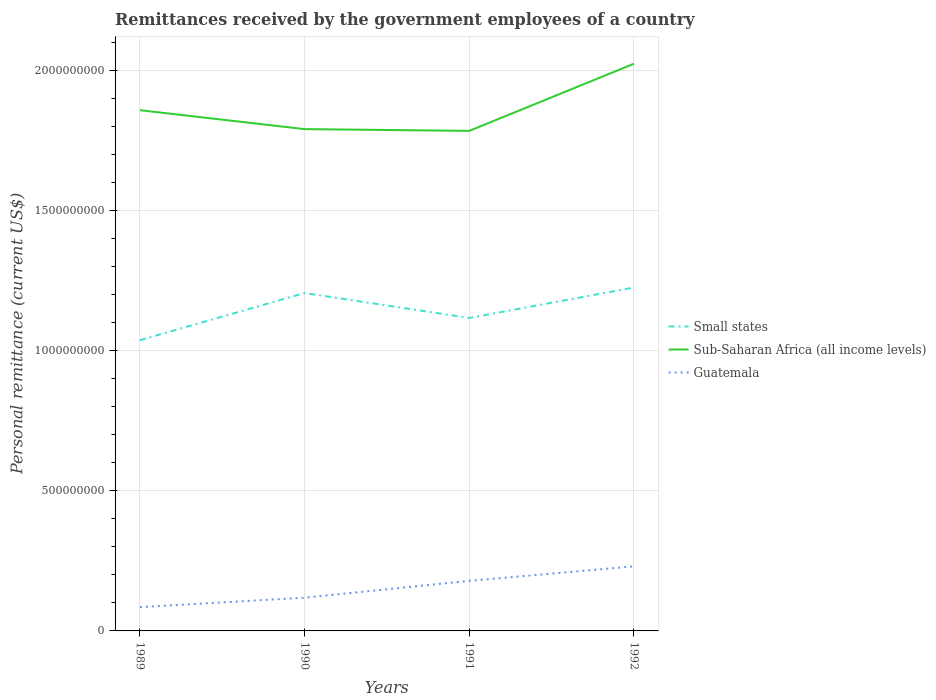How many different coloured lines are there?
Provide a succinct answer. 3. Is the number of lines equal to the number of legend labels?
Your answer should be compact. Yes. Across all years, what is the maximum remittances received by the government employees in Small states?
Your response must be concise. 1.04e+09. In which year was the remittances received by the government employees in Small states maximum?
Your answer should be very brief. 1989. What is the total remittances received by the government employees in Sub-Saharan Africa (all income levels) in the graph?
Provide a short and direct response. -2.40e+08. What is the difference between the highest and the second highest remittances received by the government employees in Small states?
Give a very brief answer. 1.88e+08. What is the difference between the highest and the lowest remittances received by the government employees in Sub-Saharan Africa (all income levels)?
Give a very brief answer. 1. How many years are there in the graph?
Your answer should be compact. 4. Are the values on the major ticks of Y-axis written in scientific E-notation?
Make the answer very short. No. How are the legend labels stacked?
Provide a short and direct response. Vertical. What is the title of the graph?
Your answer should be compact. Remittances received by the government employees of a country. Does "Low & middle income" appear as one of the legend labels in the graph?
Provide a short and direct response. No. What is the label or title of the Y-axis?
Provide a short and direct response. Personal remittance (current US$). What is the Personal remittance (current US$) of Small states in 1989?
Ensure brevity in your answer.  1.04e+09. What is the Personal remittance (current US$) of Sub-Saharan Africa (all income levels) in 1989?
Ensure brevity in your answer.  1.86e+09. What is the Personal remittance (current US$) in Guatemala in 1989?
Offer a very short reply. 8.50e+07. What is the Personal remittance (current US$) of Small states in 1990?
Offer a very short reply. 1.21e+09. What is the Personal remittance (current US$) of Sub-Saharan Africa (all income levels) in 1990?
Keep it short and to the point. 1.79e+09. What is the Personal remittance (current US$) in Guatemala in 1990?
Provide a succinct answer. 1.19e+08. What is the Personal remittance (current US$) in Small states in 1991?
Provide a succinct answer. 1.12e+09. What is the Personal remittance (current US$) in Sub-Saharan Africa (all income levels) in 1991?
Your response must be concise. 1.79e+09. What is the Personal remittance (current US$) in Guatemala in 1991?
Give a very brief answer. 1.79e+08. What is the Personal remittance (current US$) of Small states in 1992?
Your answer should be compact. 1.23e+09. What is the Personal remittance (current US$) of Sub-Saharan Africa (all income levels) in 1992?
Your answer should be very brief. 2.03e+09. What is the Personal remittance (current US$) in Guatemala in 1992?
Your response must be concise. 2.31e+08. Across all years, what is the maximum Personal remittance (current US$) of Small states?
Make the answer very short. 1.23e+09. Across all years, what is the maximum Personal remittance (current US$) in Sub-Saharan Africa (all income levels)?
Keep it short and to the point. 2.03e+09. Across all years, what is the maximum Personal remittance (current US$) of Guatemala?
Your answer should be compact. 2.31e+08. Across all years, what is the minimum Personal remittance (current US$) in Small states?
Keep it short and to the point. 1.04e+09. Across all years, what is the minimum Personal remittance (current US$) in Sub-Saharan Africa (all income levels)?
Offer a very short reply. 1.79e+09. Across all years, what is the minimum Personal remittance (current US$) of Guatemala?
Give a very brief answer. 8.50e+07. What is the total Personal remittance (current US$) of Small states in the graph?
Keep it short and to the point. 4.59e+09. What is the total Personal remittance (current US$) in Sub-Saharan Africa (all income levels) in the graph?
Your answer should be very brief. 7.46e+09. What is the total Personal remittance (current US$) in Guatemala in the graph?
Your answer should be compact. 6.13e+08. What is the difference between the Personal remittance (current US$) in Small states in 1989 and that in 1990?
Offer a terse response. -1.69e+08. What is the difference between the Personal remittance (current US$) of Sub-Saharan Africa (all income levels) in 1989 and that in 1990?
Give a very brief answer. 6.75e+07. What is the difference between the Personal remittance (current US$) in Guatemala in 1989 and that in 1990?
Your answer should be compact. -3.37e+07. What is the difference between the Personal remittance (current US$) of Small states in 1989 and that in 1991?
Your answer should be compact. -7.95e+07. What is the difference between the Personal remittance (current US$) of Sub-Saharan Africa (all income levels) in 1989 and that in 1991?
Make the answer very short. 7.39e+07. What is the difference between the Personal remittance (current US$) in Guatemala in 1989 and that in 1991?
Your answer should be compact. -9.39e+07. What is the difference between the Personal remittance (current US$) of Small states in 1989 and that in 1992?
Offer a terse response. -1.88e+08. What is the difference between the Personal remittance (current US$) in Sub-Saharan Africa (all income levels) in 1989 and that in 1992?
Make the answer very short. -1.66e+08. What is the difference between the Personal remittance (current US$) in Guatemala in 1989 and that in 1992?
Provide a short and direct response. -1.46e+08. What is the difference between the Personal remittance (current US$) in Small states in 1990 and that in 1991?
Provide a succinct answer. 8.90e+07. What is the difference between the Personal remittance (current US$) in Sub-Saharan Africa (all income levels) in 1990 and that in 1991?
Your response must be concise. 6.35e+06. What is the difference between the Personal remittance (current US$) in Guatemala in 1990 and that in 1991?
Give a very brief answer. -6.02e+07. What is the difference between the Personal remittance (current US$) of Small states in 1990 and that in 1992?
Provide a short and direct response. -1.97e+07. What is the difference between the Personal remittance (current US$) of Sub-Saharan Africa (all income levels) in 1990 and that in 1992?
Keep it short and to the point. -2.33e+08. What is the difference between the Personal remittance (current US$) of Guatemala in 1990 and that in 1992?
Make the answer very short. -1.12e+08. What is the difference between the Personal remittance (current US$) in Small states in 1991 and that in 1992?
Your answer should be very brief. -1.09e+08. What is the difference between the Personal remittance (current US$) of Sub-Saharan Africa (all income levels) in 1991 and that in 1992?
Make the answer very short. -2.40e+08. What is the difference between the Personal remittance (current US$) in Guatemala in 1991 and that in 1992?
Your response must be concise. -5.17e+07. What is the difference between the Personal remittance (current US$) of Small states in 1989 and the Personal remittance (current US$) of Sub-Saharan Africa (all income levels) in 1990?
Offer a terse response. -7.54e+08. What is the difference between the Personal remittance (current US$) in Small states in 1989 and the Personal remittance (current US$) in Guatemala in 1990?
Provide a short and direct response. 9.20e+08. What is the difference between the Personal remittance (current US$) of Sub-Saharan Africa (all income levels) in 1989 and the Personal remittance (current US$) of Guatemala in 1990?
Your response must be concise. 1.74e+09. What is the difference between the Personal remittance (current US$) in Small states in 1989 and the Personal remittance (current US$) in Sub-Saharan Africa (all income levels) in 1991?
Give a very brief answer. -7.48e+08. What is the difference between the Personal remittance (current US$) in Small states in 1989 and the Personal remittance (current US$) in Guatemala in 1991?
Your answer should be compact. 8.59e+08. What is the difference between the Personal remittance (current US$) in Sub-Saharan Africa (all income levels) in 1989 and the Personal remittance (current US$) in Guatemala in 1991?
Make the answer very short. 1.68e+09. What is the difference between the Personal remittance (current US$) in Small states in 1989 and the Personal remittance (current US$) in Sub-Saharan Africa (all income levels) in 1992?
Provide a succinct answer. -9.87e+08. What is the difference between the Personal remittance (current US$) in Small states in 1989 and the Personal remittance (current US$) in Guatemala in 1992?
Ensure brevity in your answer.  8.08e+08. What is the difference between the Personal remittance (current US$) in Sub-Saharan Africa (all income levels) in 1989 and the Personal remittance (current US$) in Guatemala in 1992?
Your answer should be very brief. 1.63e+09. What is the difference between the Personal remittance (current US$) of Small states in 1990 and the Personal remittance (current US$) of Sub-Saharan Africa (all income levels) in 1991?
Your answer should be compact. -5.79e+08. What is the difference between the Personal remittance (current US$) of Small states in 1990 and the Personal remittance (current US$) of Guatemala in 1991?
Provide a succinct answer. 1.03e+09. What is the difference between the Personal remittance (current US$) of Sub-Saharan Africa (all income levels) in 1990 and the Personal remittance (current US$) of Guatemala in 1991?
Your answer should be very brief. 1.61e+09. What is the difference between the Personal remittance (current US$) of Small states in 1990 and the Personal remittance (current US$) of Sub-Saharan Africa (all income levels) in 1992?
Provide a short and direct response. -8.19e+08. What is the difference between the Personal remittance (current US$) of Small states in 1990 and the Personal remittance (current US$) of Guatemala in 1992?
Provide a succinct answer. 9.76e+08. What is the difference between the Personal remittance (current US$) in Sub-Saharan Africa (all income levels) in 1990 and the Personal remittance (current US$) in Guatemala in 1992?
Make the answer very short. 1.56e+09. What is the difference between the Personal remittance (current US$) in Small states in 1991 and the Personal remittance (current US$) in Sub-Saharan Africa (all income levels) in 1992?
Offer a very short reply. -9.08e+08. What is the difference between the Personal remittance (current US$) in Small states in 1991 and the Personal remittance (current US$) in Guatemala in 1992?
Offer a terse response. 8.87e+08. What is the difference between the Personal remittance (current US$) of Sub-Saharan Africa (all income levels) in 1991 and the Personal remittance (current US$) of Guatemala in 1992?
Your response must be concise. 1.56e+09. What is the average Personal remittance (current US$) in Small states per year?
Provide a short and direct response. 1.15e+09. What is the average Personal remittance (current US$) in Sub-Saharan Africa (all income levels) per year?
Give a very brief answer. 1.87e+09. What is the average Personal remittance (current US$) in Guatemala per year?
Make the answer very short. 1.53e+08. In the year 1989, what is the difference between the Personal remittance (current US$) in Small states and Personal remittance (current US$) in Sub-Saharan Africa (all income levels)?
Offer a terse response. -8.22e+08. In the year 1989, what is the difference between the Personal remittance (current US$) in Small states and Personal remittance (current US$) in Guatemala?
Offer a terse response. 9.53e+08. In the year 1989, what is the difference between the Personal remittance (current US$) of Sub-Saharan Africa (all income levels) and Personal remittance (current US$) of Guatemala?
Give a very brief answer. 1.77e+09. In the year 1990, what is the difference between the Personal remittance (current US$) of Small states and Personal remittance (current US$) of Sub-Saharan Africa (all income levels)?
Make the answer very short. -5.85e+08. In the year 1990, what is the difference between the Personal remittance (current US$) in Small states and Personal remittance (current US$) in Guatemala?
Offer a terse response. 1.09e+09. In the year 1990, what is the difference between the Personal remittance (current US$) of Sub-Saharan Africa (all income levels) and Personal remittance (current US$) of Guatemala?
Your response must be concise. 1.67e+09. In the year 1991, what is the difference between the Personal remittance (current US$) in Small states and Personal remittance (current US$) in Sub-Saharan Africa (all income levels)?
Provide a succinct answer. -6.68e+08. In the year 1991, what is the difference between the Personal remittance (current US$) in Small states and Personal remittance (current US$) in Guatemala?
Your answer should be compact. 9.39e+08. In the year 1991, what is the difference between the Personal remittance (current US$) in Sub-Saharan Africa (all income levels) and Personal remittance (current US$) in Guatemala?
Offer a terse response. 1.61e+09. In the year 1992, what is the difference between the Personal remittance (current US$) in Small states and Personal remittance (current US$) in Sub-Saharan Africa (all income levels)?
Make the answer very short. -7.99e+08. In the year 1992, what is the difference between the Personal remittance (current US$) in Small states and Personal remittance (current US$) in Guatemala?
Your answer should be very brief. 9.96e+08. In the year 1992, what is the difference between the Personal remittance (current US$) in Sub-Saharan Africa (all income levels) and Personal remittance (current US$) in Guatemala?
Keep it short and to the point. 1.80e+09. What is the ratio of the Personal remittance (current US$) in Small states in 1989 to that in 1990?
Make the answer very short. 0.86. What is the ratio of the Personal remittance (current US$) of Sub-Saharan Africa (all income levels) in 1989 to that in 1990?
Keep it short and to the point. 1.04. What is the ratio of the Personal remittance (current US$) in Guatemala in 1989 to that in 1990?
Offer a very short reply. 0.72. What is the ratio of the Personal remittance (current US$) in Small states in 1989 to that in 1991?
Make the answer very short. 0.93. What is the ratio of the Personal remittance (current US$) of Sub-Saharan Africa (all income levels) in 1989 to that in 1991?
Make the answer very short. 1.04. What is the ratio of the Personal remittance (current US$) of Guatemala in 1989 to that in 1991?
Provide a short and direct response. 0.48. What is the ratio of the Personal remittance (current US$) of Small states in 1989 to that in 1992?
Provide a succinct answer. 0.85. What is the ratio of the Personal remittance (current US$) of Sub-Saharan Africa (all income levels) in 1989 to that in 1992?
Offer a very short reply. 0.92. What is the ratio of the Personal remittance (current US$) in Guatemala in 1989 to that in 1992?
Your answer should be compact. 0.37. What is the ratio of the Personal remittance (current US$) of Small states in 1990 to that in 1991?
Give a very brief answer. 1.08. What is the ratio of the Personal remittance (current US$) in Sub-Saharan Africa (all income levels) in 1990 to that in 1991?
Provide a short and direct response. 1. What is the ratio of the Personal remittance (current US$) of Guatemala in 1990 to that in 1991?
Offer a very short reply. 0.66. What is the ratio of the Personal remittance (current US$) in Sub-Saharan Africa (all income levels) in 1990 to that in 1992?
Provide a short and direct response. 0.88. What is the ratio of the Personal remittance (current US$) in Guatemala in 1990 to that in 1992?
Offer a very short reply. 0.51. What is the ratio of the Personal remittance (current US$) of Small states in 1991 to that in 1992?
Offer a very short reply. 0.91. What is the ratio of the Personal remittance (current US$) in Sub-Saharan Africa (all income levels) in 1991 to that in 1992?
Provide a short and direct response. 0.88. What is the ratio of the Personal remittance (current US$) of Guatemala in 1991 to that in 1992?
Your answer should be very brief. 0.78. What is the difference between the highest and the second highest Personal remittance (current US$) of Small states?
Your answer should be very brief. 1.97e+07. What is the difference between the highest and the second highest Personal remittance (current US$) of Sub-Saharan Africa (all income levels)?
Ensure brevity in your answer.  1.66e+08. What is the difference between the highest and the second highest Personal remittance (current US$) in Guatemala?
Your answer should be compact. 5.17e+07. What is the difference between the highest and the lowest Personal remittance (current US$) in Small states?
Offer a very short reply. 1.88e+08. What is the difference between the highest and the lowest Personal remittance (current US$) of Sub-Saharan Africa (all income levels)?
Make the answer very short. 2.40e+08. What is the difference between the highest and the lowest Personal remittance (current US$) in Guatemala?
Your answer should be very brief. 1.46e+08. 